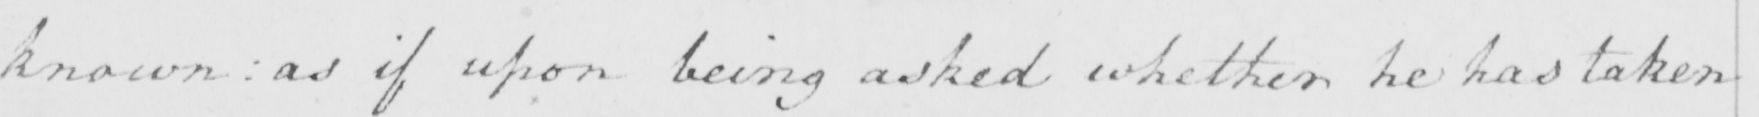Transcribe the text shown in this historical manuscript line. known :  as if upon being asked whether he has taken 